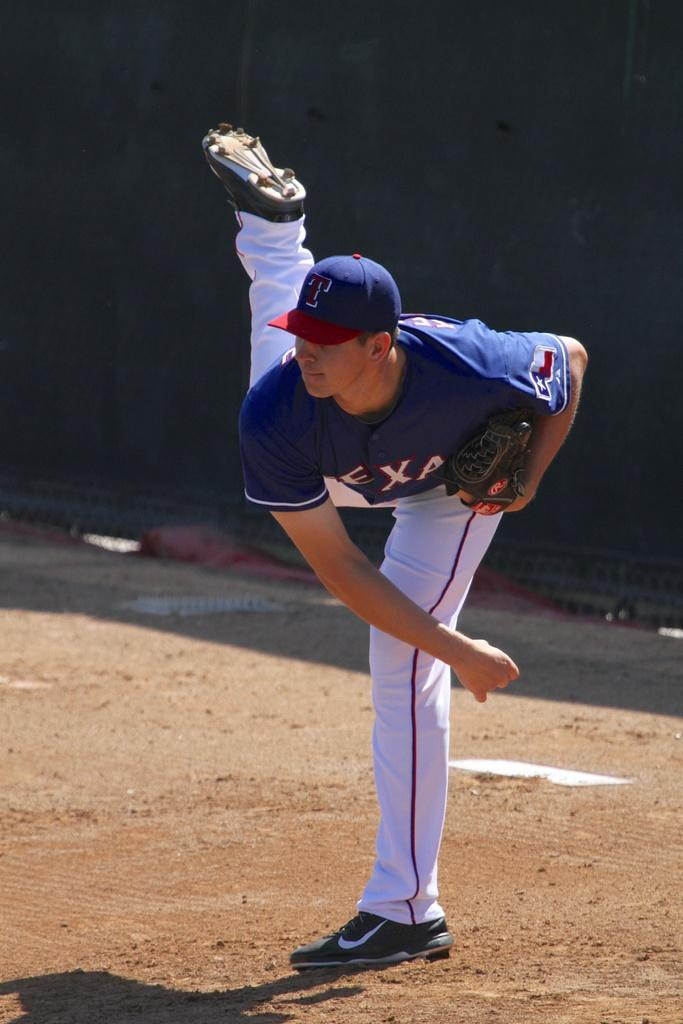<image>
Summarize the visual content of the image. a man in a jersey with letters EXA just finished throwing a ball 